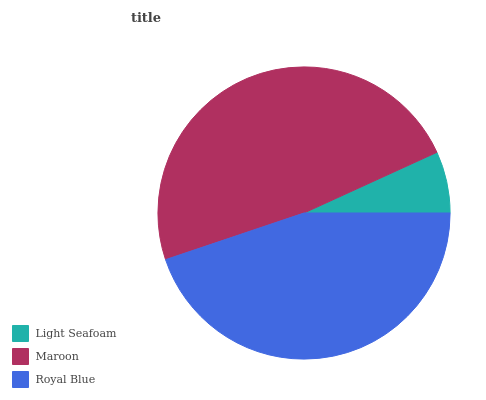Is Light Seafoam the minimum?
Answer yes or no. Yes. Is Maroon the maximum?
Answer yes or no. Yes. Is Royal Blue the minimum?
Answer yes or no. No. Is Royal Blue the maximum?
Answer yes or no. No. Is Maroon greater than Royal Blue?
Answer yes or no. Yes. Is Royal Blue less than Maroon?
Answer yes or no. Yes. Is Royal Blue greater than Maroon?
Answer yes or no. No. Is Maroon less than Royal Blue?
Answer yes or no. No. Is Royal Blue the high median?
Answer yes or no. Yes. Is Royal Blue the low median?
Answer yes or no. Yes. Is Maroon the high median?
Answer yes or no. No. Is Light Seafoam the low median?
Answer yes or no. No. 